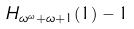Convert formula to latex. <formula><loc_0><loc_0><loc_500><loc_500>H _ { \omega ^ { \omega } + \omega + 1 } ( 1 ) - 1</formula> 